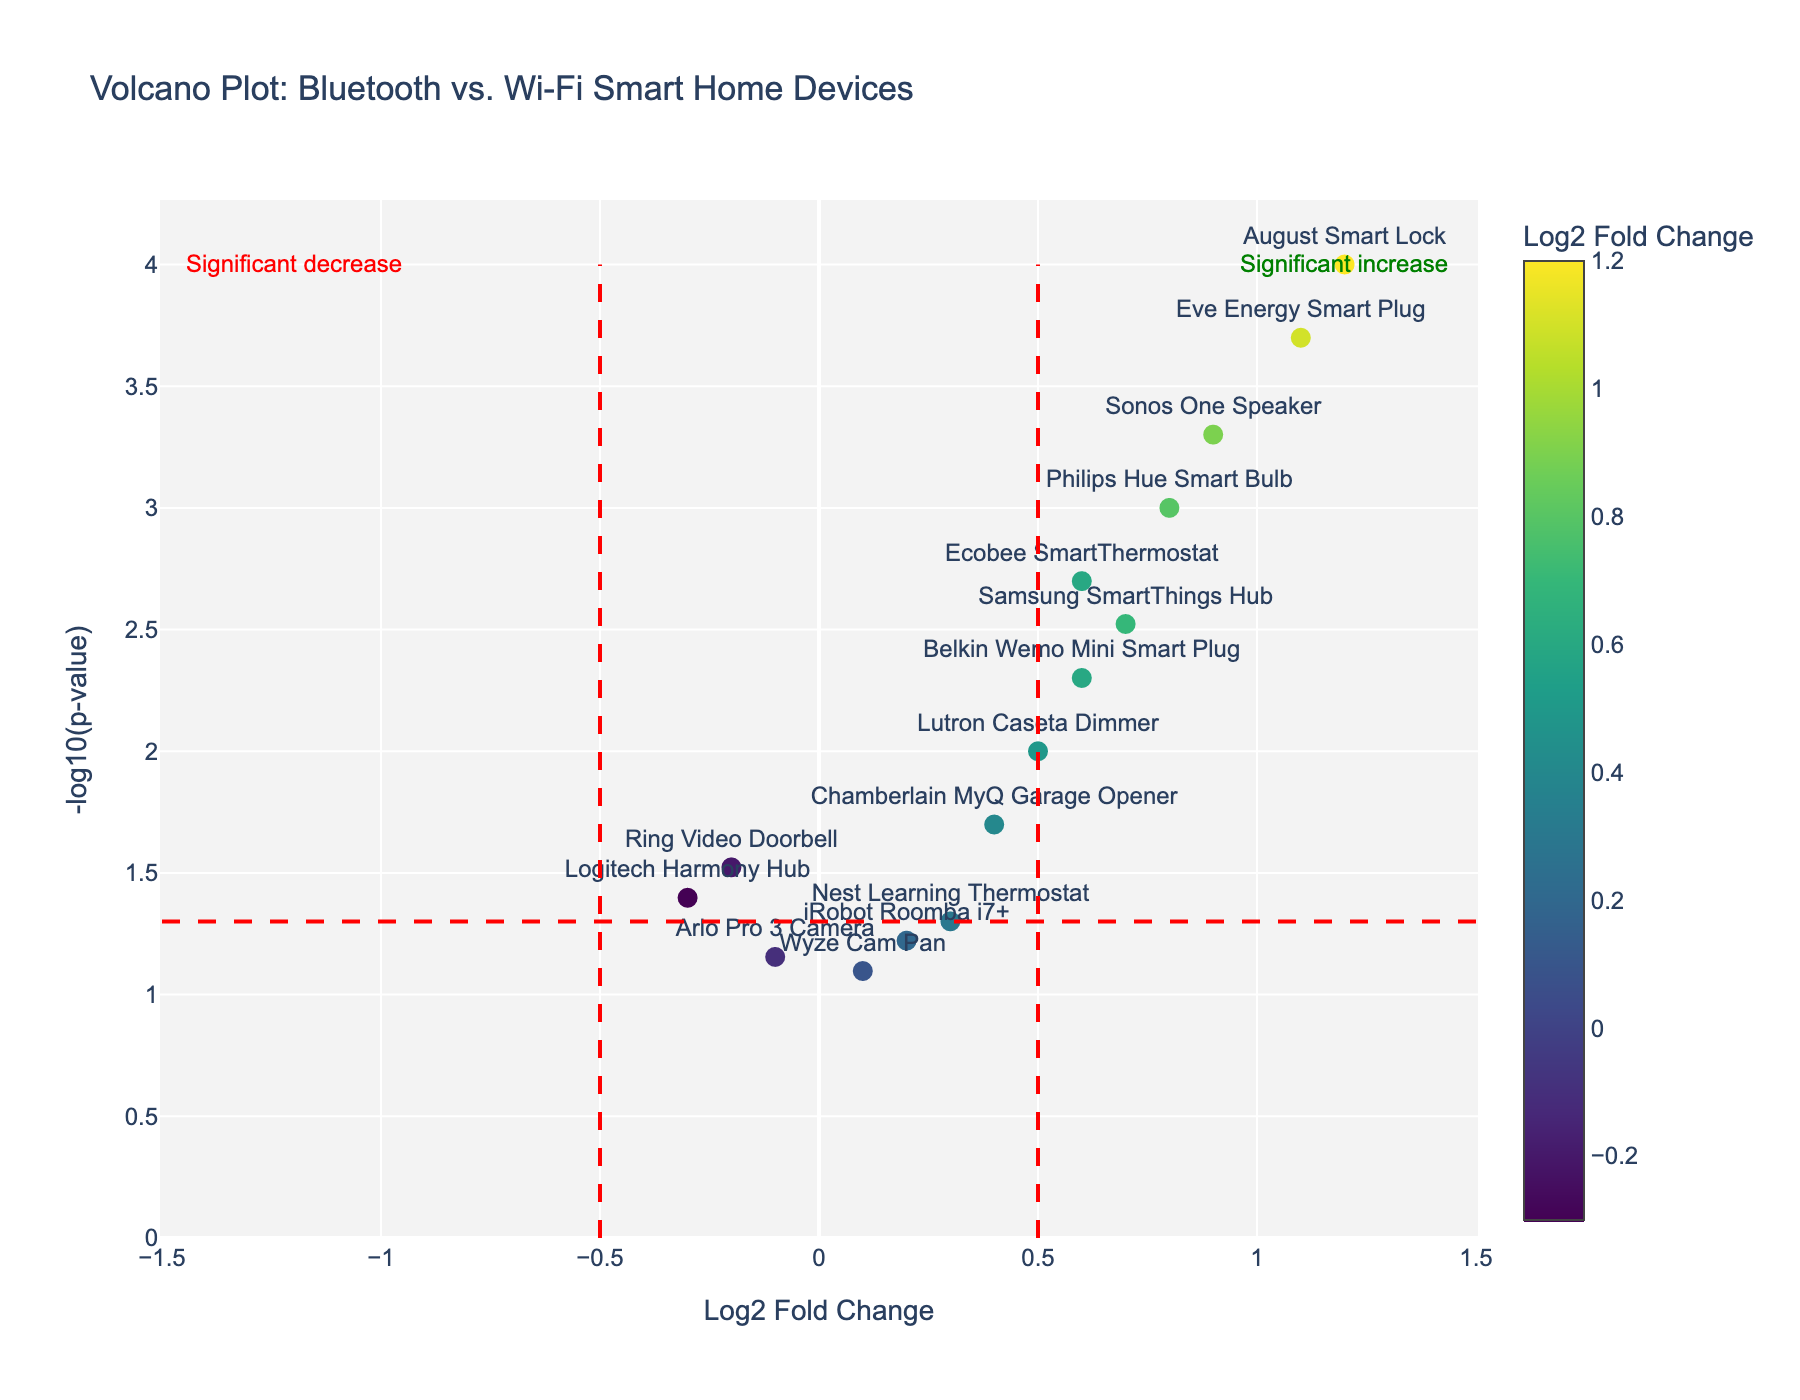what is the title of the plot? The title is prominently displayed at the top of the figure. It provides an overview of the content and objective of the plot.
Answer: Volcano Plot: Bluetooth vs. Wi-Fi Smart Home Devices what are the axes titles on the plot? The x-axis and y-axis titles are shown on the plot to explain what each axis represents. The x-axis represents the Log2 Fold Change, while the y-axis represents -log10(p-value).
Answer: Log2 Fold Change and -log10(p-value) How many devices have a positive log2 fold change? By counting the number of data points to the right of the vertical line at x=0 on the x-axis, you can determine the number of devices with a positive log2 fold change.
Answer: 10 What is the name of the device with the highest log2 fold change? The highest log2 fold change corresponds to the data point positioned farthest to the right on the x-axis. The hover text identifies this device.
Answer: August Smart Lock Which device has the lowest p-value? The device with the lowest p-value will be at the highest point on the y-axis (-log10(p-value)). The hover text will help identify this device.
Answer: August Smart Lock Are there more devices with a log2 fold change greater than 0.5 or less than 0.5? Count the number of data points to the right of the vertical line at x=0.5 and compare it to the number of data points to the left of x=0.5.
Answer: More devices have a log2 fold change greater than 0.5 How many devices have a p-value less than 0.05? Determine which devices lie above the horizontal line at y=1.3, as -log10(0.05) is approximately 1.3. Count these data points.
Answer: 8 Which device is nearest to a neutral log2 fold change (0)? The device closest to x=0 on the x-axis with the smallest absolute log2 fold change is the required device. You can identify it using hover text.
Answer: Wyze Cam Pan Which device has a log2 fold change of approximately 0.9 and what is its p-value? Locate the data point around x=0.9 on the x-axis, then use hover text to find additional details, including the p-value.
Answer: Sonos One Speaker; p-value is 0.0005 Which device has a significant decrease in user adoption rate? Devices with a significant decrease in user adoption rate will be to the left of the vertical line at x=-0.5 and above the horizontal line at y=1.3. Hover text reveals the device name.
Answer: Logitech Harmony Hub 